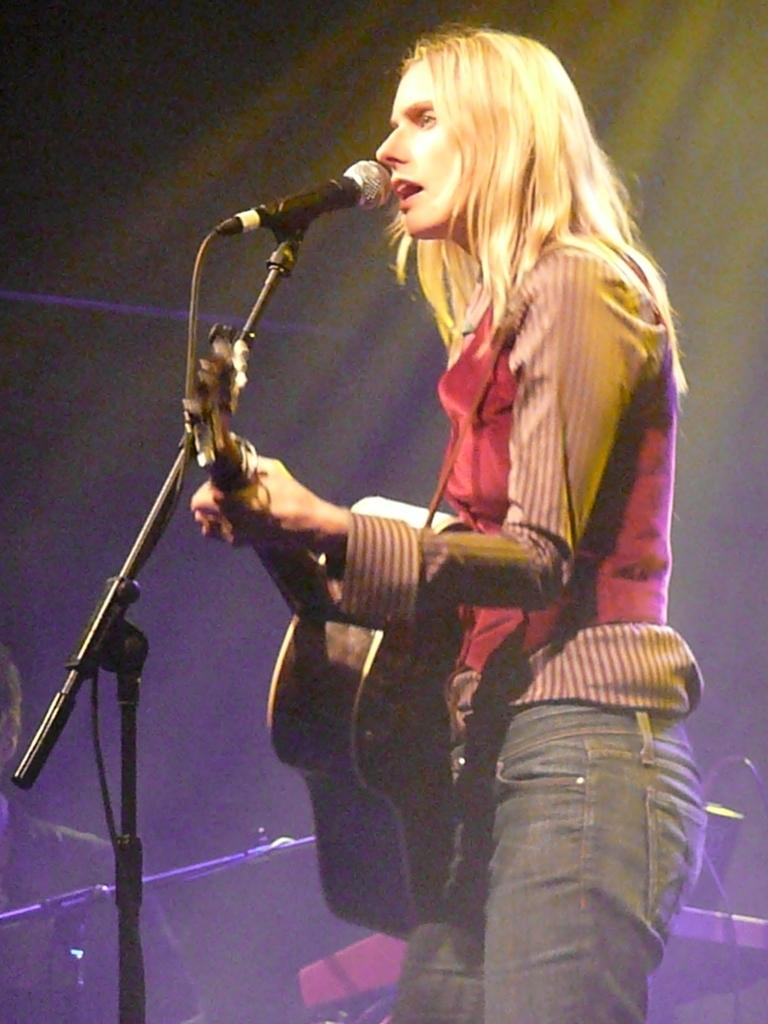Who is the main subject in the image? There is a woman in the image. What is the woman wearing? The woman is wearing a red shirt. What is the woman holding in the image? The woman is holding a guitar. What is the woman doing in the image? The woman is singing a song. Who else is present in the image? There is a man in the image. What equipment is visible in the image? There is a microphone with a stand and music systems visible in the image. How many kittens are playing with the microphone stand in the image? There are no kittens present in the image. 